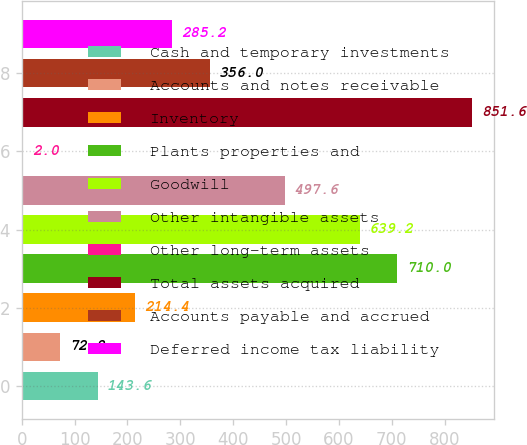Convert chart to OTSL. <chart><loc_0><loc_0><loc_500><loc_500><bar_chart><fcel>Cash and temporary investments<fcel>Accounts and notes receivable<fcel>Inventory<fcel>Plants properties and<fcel>Goodwill<fcel>Other intangible assets<fcel>Other long-term assets<fcel>Total assets acquired<fcel>Accounts payable and accrued<fcel>Deferred income tax liability<nl><fcel>143.6<fcel>72.8<fcel>214.4<fcel>710<fcel>639.2<fcel>497.6<fcel>2<fcel>851.6<fcel>356<fcel>285.2<nl></chart> 